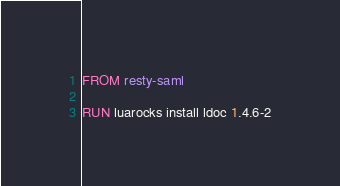<code> <loc_0><loc_0><loc_500><loc_500><_Dockerfile_>FROM resty-saml

RUN luarocks install ldoc 1.4.6-2
</code> 